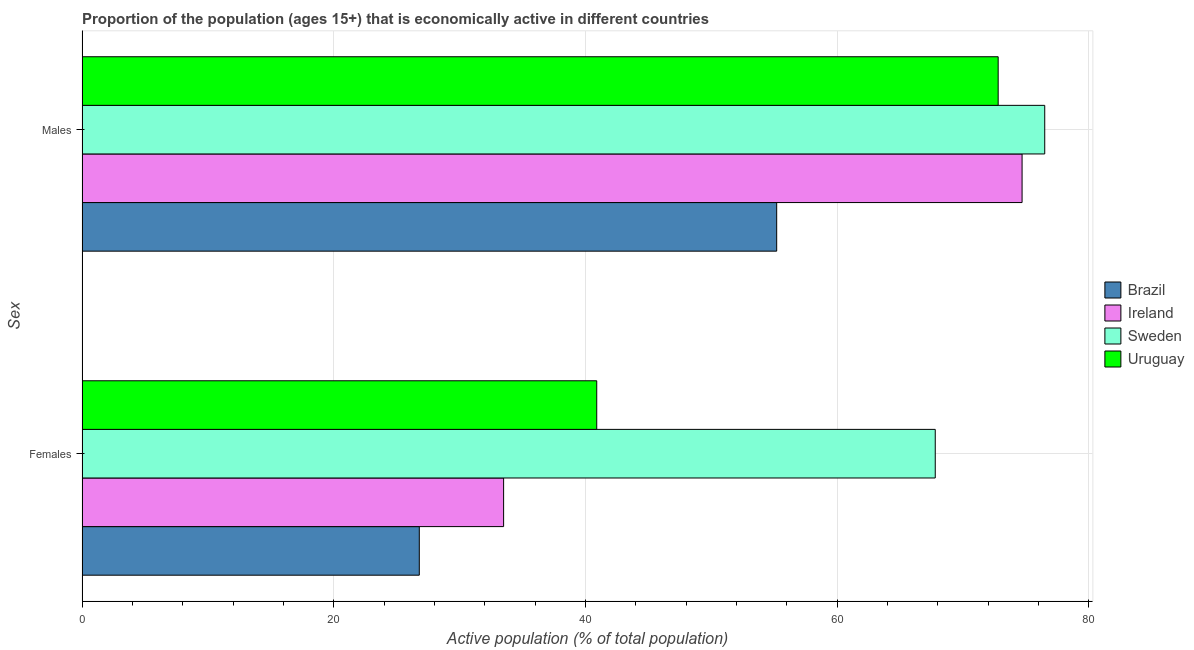How many groups of bars are there?
Your answer should be very brief. 2. How many bars are there on the 2nd tick from the top?
Ensure brevity in your answer.  4. What is the label of the 1st group of bars from the top?
Offer a terse response. Males. What is the percentage of economically active male population in Uruguay?
Provide a short and direct response. 72.8. Across all countries, what is the maximum percentage of economically active male population?
Keep it short and to the point. 76.5. Across all countries, what is the minimum percentage of economically active male population?
Your response must be concise. 55.2. What is the total percentage of economically active male population in the graph?
Ensure brevity in your answer.  279.2. What is the difference between the percentage of economically active female population in Brazil and that in Ireland?
Provide a succinct answer. -6.7. What is the difference between the percentage of economically active female population in Uruguay and the percentage of economically active male population in Sweden?
Keep it short and to the point. -35.6. What is the average percentage of economically active female population per country?
Your answer should be compact. 42.25. What is the difference between the percentage of economically active female population and percentage of economically active male population in Ireland?
Keep it short and to the point. -41.2. In how many countries, is the percentage of economically active female population greater than 16 %?
Provide a succinct answer. 4. What is the ratio of the percentage of economically active female population in Sweden to that in Uruguay?
Make the answer very short. 1.66. Is the percentage of economically active male population in Brazil less than that in Sweden?
Give a very brief answer. Yes. In how many countries, is the percentage of economically active male population greater than the average percentage of economically active male population taken over all countries?
Provide a short and direct response. 3. What does the 4th bar from the bottom in Females represents?
Provide a succinct answer. Uruguay. How many countries are there in the graph?
Provide a succinct answer. 4. What is the difference between two consecutive major ticks on the X-axis?
Your answer should be compact. 20. Are the values on the major ticks of X-axis written in scientific E-notation?
Your answer should be very brief. No. Does the graph contain grids?
Offer a terse response. Yes. How many legend labels are there?
Provide a short and direct response. 4. How are the legend labels stacked?
Provide a short and direct response. Vertical. What is the title of the graph?
Your response must be concise. Proportion of the population (ages 15+) that is economically active in different countries. What is the label or title of the X-axis?
Keep it short and to the point. Active population (% of total population). What is the label or title of the Y-axis?
Provide a short and direct response. Sex. What is the Active population (% of total population) in Brazil in Females?
Provide a short and direct response. 26.8. What is the Active population (% of total population) in Ireland in Females?
Provide a short and direct response. 33.5. What is the Active population (% of total population) of Sweden in Females?
Your answer should be compact. 67.8. What is the Active population (% of total population) in Uruguay in Females?
Offer a very short reply. 40.9. What is the Active population (% of total population) of Brazil in Males?
Provide a succinct answer. 55.2. What is the Active population (% of total population) in Ireland in Males?
Ensure brevity in your answer.  74.7. What is the Active population (% of total population) of Sweden in Males?
Give a very brief answer. 76.5. What is the Active population (% of total population) of Uruguay in Males?
Your response must be concise. 72.8. Across all Sex, what is the maximum Active population (% of total population) in Brazil?
Ensure brevity in your answer.  55.2. Across all Sex, what is the maximum Active population (% of total population) of Ireland?
Keep it short and to the point. 74.7. Across all Sex, what is the maximum Active population (% of total population) of Sweden?
Your answer should be compact. 76.5. Across all Sex, what is the maximum Active population (% of total population) of Uruguay?
Keep it short and to the point. 72.8. Across all Sex, what is the minimum Active population (% of total population) of Brazil?
Provide a short and direct response. 26.8. Across all Sex, what is the minimum Active population (% of total population) in Ireland?
Keep it short and to the point. 33.5. Across all Sex, what is the minimum Active population (% of total population) of Sweden?
Ensure brevity in your answer.  67.8. Across all Sex, what is the minimum Active population (% of total population) in Uruguay?
Your answer should be compact. 40.9. What is the total Active population (% of total population) in Ireland in the graph?
Keep it short and to the point. 108.2. What is the total Active population (% of total population) in Sweden in the graph?
Provide a short and direct response. 144.3. What is the total Active population (% of total population) in Uruguay in the graph?
Offer a terse response. 113.7. What is the difference between the Active population (% of total population) in Brazil in Females and that in Males?
Your answer should be compact. -28.4. What is the difference between the Active population (% of total population) of Ireland in Females and that in Males?
Provide a short and direct response. -41.2. What is the difference between the Active population (% of total population) of Uruguay in Females and that in Males?
Make the answer very short. -31.9. What is the difference between the Active population (% of total population) in Brazil in Females and the Active population (% of total population) in Ireland in Males?
Your answer should be very brief. -47.9. What is the difference between the Active population (% of total population) in Brazil in Females and the Active population (% of total population) in Sweden in Males?
Provide a short and direct response. -49.7. What is the difference between the Active population (% of total population) in Brazil in Females and the Active population (% of total population) in Uruguay in Males?
Provide a short and direct response. -46. What is the difference between the Active population (% of total population) in Ireland in Females and the Active population (% of total population) in Sweden in Males?
Ensure brevity in your answer.  -43. What is the difference between the Active population (% of total population) in Ireland in Females and the Active population (% of total population) in Uruguay in Males?
Your answer should be very brief. -39.3. What is the average Active population (% of total population) of Brazil per Sex?
Your answer should be very brief. 41. What is the average Active population (% of total population) of Ireland per Sex?
Keep it short and to the point. 54.1. What is the average Active population (% of total population) in Sweden per Sex?
Your response must be concise. 72.15. What is the average Active population (% of total population) in Uruguay per Sex?
Offer a terse response. 56.85. What is the difference between the Active population (% of total population) in Brazil and Active population (% of total population) in Ireland in Females?
Your answer should be compact. -6.7. What is the difference between the Active population (% of total population) in Brazil and Active population (% of total population) in Sweden in Females?
Give a very brief answer. -41. What is the difference between the Active population (% of total population) of Brazil and Active population (% of total population) of Uruguay in Females?
Your answer should be very brief. -14.1. What is the difference between the Active population (% of total population) of Ireland and Active population (% of total population) of Sweden in Females?
Provide a succinct answer. -34.3. What is the difference between the Active population (% of total population) in Ireland and Active population (% of total population) in Uruguay in Females?
Make the answer very short. -7.4. What is the difference between the Active population (% of total population) in Sweden and Active population (% of total population) in Uruguay in Females?
Your answer should be very brief. 26.9. What is the difference between the Active population (% of total population) in Brazil and Active population (% of total population) in Ireland in Males?
Your answer should be compact. -19.5. What is the difference between the Active population (% of total population) in Brazil and Active population (% of total population) in Sweden in Males?
Your answer should be very brief. -21.3. What is the difference between the Active population (% of total population) of Brazil and Active population (% of total population) of Uruguay in Males?
Make the answer very short. -17.6. What is the difference between the Active population (% of total population) in Ireland and Active population (% of total population) in Sweden in Males?
Your answer should be compact. -1.8. What is the ratio of the Active population (% of total population) in Brazil in Females to that in Males?
Make the answer very short. 0.49. What is the ratio of the Active population (% of total population) of Ireland in Females to that in Males?
Offer a terse response. 0.45. What is the ratio of the Active population (% of total population) of Sweden in Females to that in Males?
Offer a very short reply. 0.89. What is the ratio of the Active population (% of total population) in Uruguay in Females to that in Males?
Provide a short and direct response. 0.56. What is the difference between the highest and the second highest Active population (% of total population) in Brazil?
Provide a short and direct response. 28.4. What is the difference between the highest and the second highest Active population (% of total population) in Ireland?
Your answer should be very brief. 41.2. What is the difference between the highest and the second highest Active population (% of total population) in Uruguay?
Provide a short and direct response. 31.9. What is the difference between the highest and the lowest Active population (% of total population) in Brazil?
Give a very brief answer. 28.4. What is the difference between the highest and the lowest Active population (% of total population) in Ireland?
Keep it short and to the point. 41.2. What is the difference between the highest and the lowest Active population (% of total population) of Uruguay?
Give a very brief answer. 31.9. 